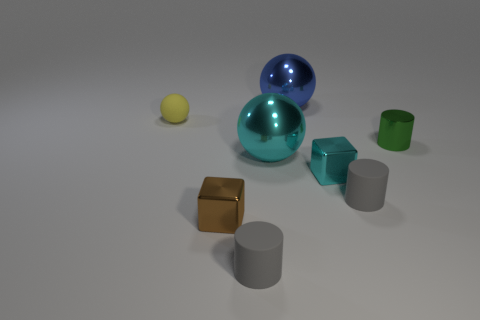Can you describe the lighting in this scene? The lighting in the scene appears to be diffused and soft, casting gentle shadows directly beneath the objects with no harsh contrasts, suggesting an overcast or filtered light source. 